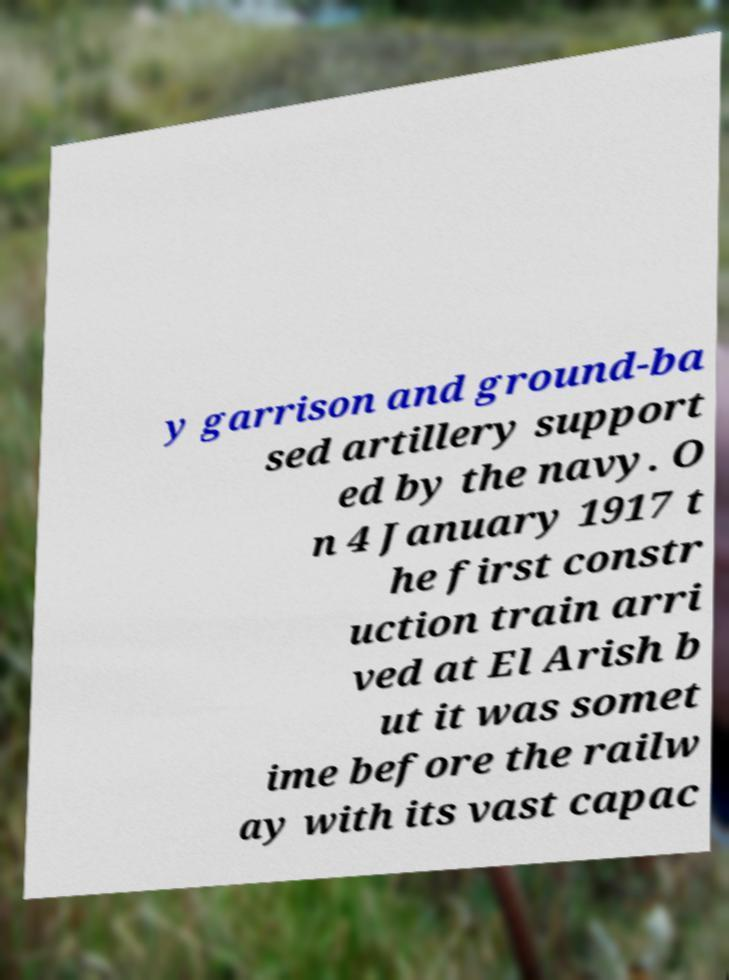Can you read and provide the text displayed in the image?This photo seems to have some interesting text. Can you extract and type it out for me? y garrison and ground-ba sed artillery support ed by the navy. O n 4 January 1917 t he first constr uction train arri ved at El Arish b ut it was somet ime before the railw ay with its vast capac 